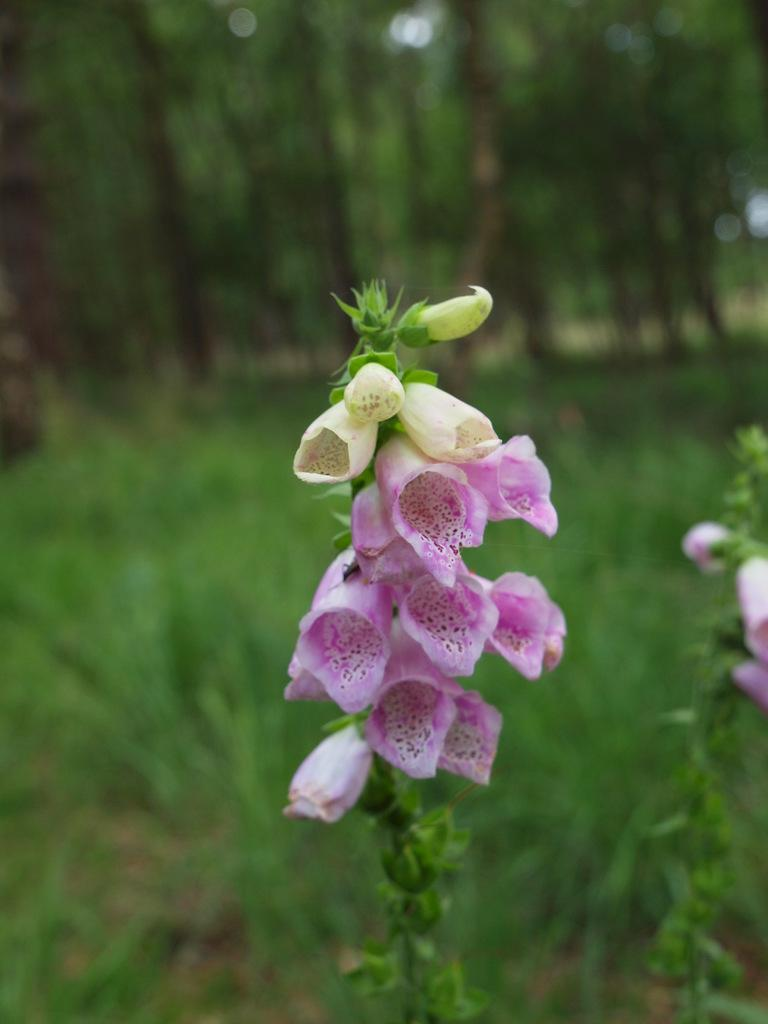What is the main subject of the image? There is a plant in the center of the image. What can be observed about the plant? The plant has flowers. What can be seen in the background of the image? There are trees in the background of the image. Can you see any fairies dancing around the plant in the image? There are no fairies present in the image. What type of shop can be seen in the background of the image? There is no shop visible in the image; it only features a plant and trees in the background. 